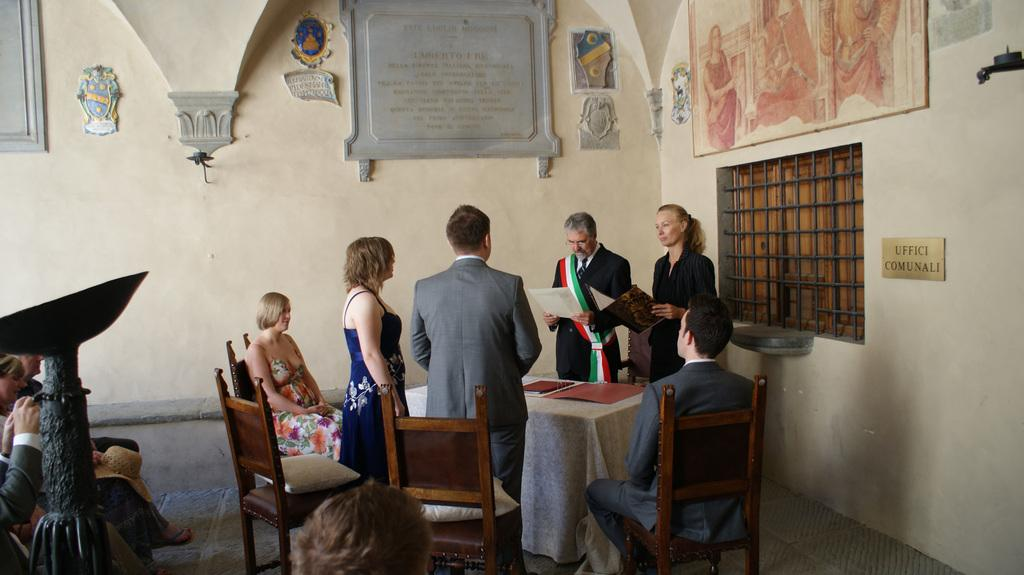How many people are in the image? There is a group of people in the image, but the exact number is not specified. What are some of the people in the image doing? Some people are standing, and some people are sitting on chairs. What can be seen on the wall in the image? There are frames on the wall. What type of sea creature is visible in the image? There is no sea creature present in the image. What kind of bait is being used by the people in the image? There is no indication of fishing or the use of bait in the image. 